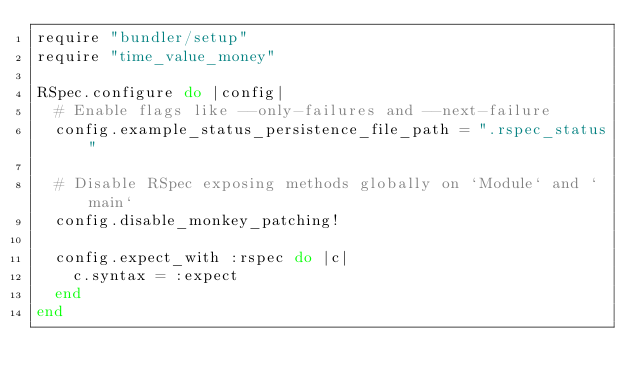Convert code to text. <code><loc_0><loc_0><loc_500><loc_500><_Ruby_>require "bundler/setup"
require "time_value_money"

RSpec.configure do |config|
  # Enable flags like --only-failures and --next-failure
  config.example_status_persistence_file_path = ".rspec_status"

  # Disable RSpec exposing methods globally on `Module` and `main`
  config.disable_monkey_patching!

  config.expect_with :rspec do |c|
    c.syntax = :expect
  end
end
</code> 